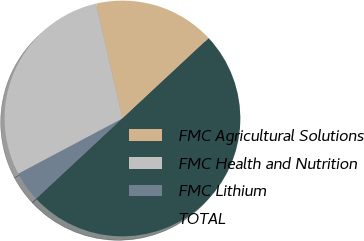Convert chart. <chart><loc_0><loc_0><loc_500><loc_500><pie_chart><fcel>FMC Agricultural Solutions<fcel>FMC Health and Nutrition<fcel>FMC Lithium<fcel>TOTAL<nl><fcel>16.67%<fcel>29.17%<fcel>4.17%<fcel>50.0%<nl></chart> 